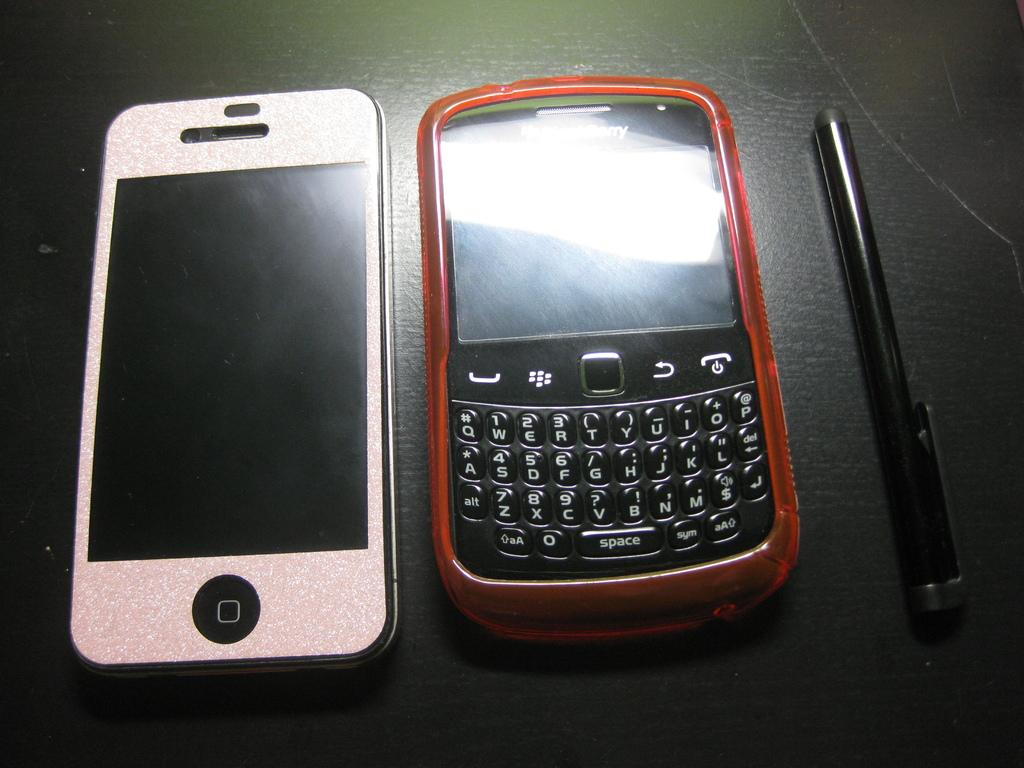<image>
Render a clear and concise summary of the photo. Two cell phones laying next to each other one says it's a Blackberry on it. 